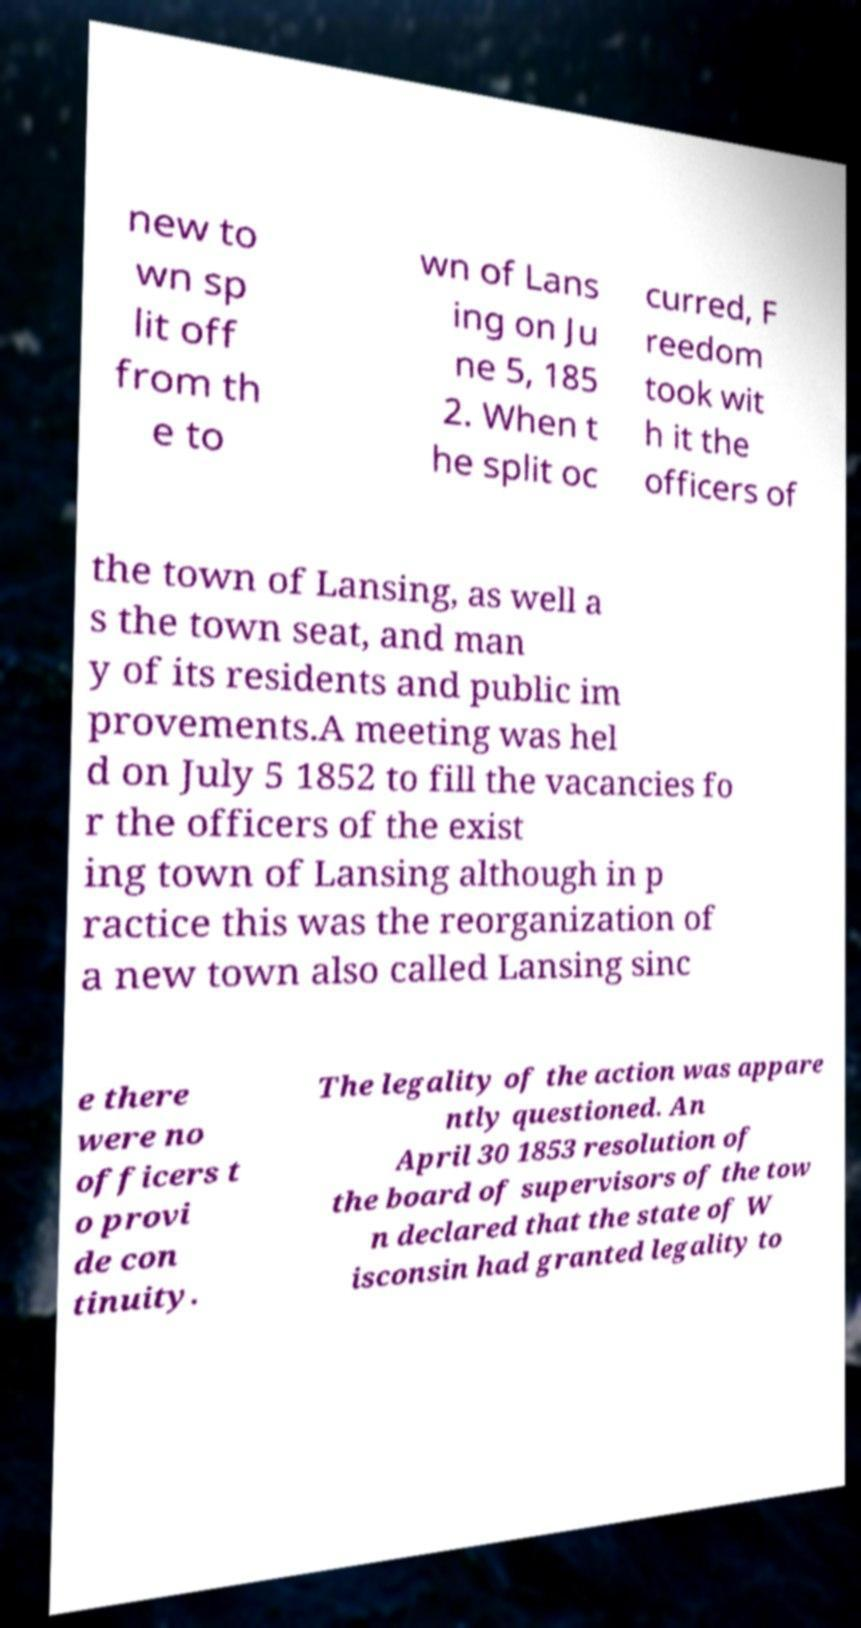There's text embedded in this image that I need extracted. Can you transcribe it verbatim? new to wn sp lit off from th e to wn of Lans ing on Ju ne 5, 185 2. When t he split oc curred, F reedom took wit h it the officers of the town of Lansing, as well a s the town seat, and man y of its residents and public im provements.A meeting was hel d on July 5 1852 to fill the vacancies fo r the officers of the exist ing town of Lansing although in p ractice this was the reorganization of a new town also called Lansing sinc e there were no officers t o provi de con tinuity. The legality of the action was appare ntly questioned. An April 30 1853 resolution of the board of supervisors of the tow n declared that the state of W isconsin had granted legality to 